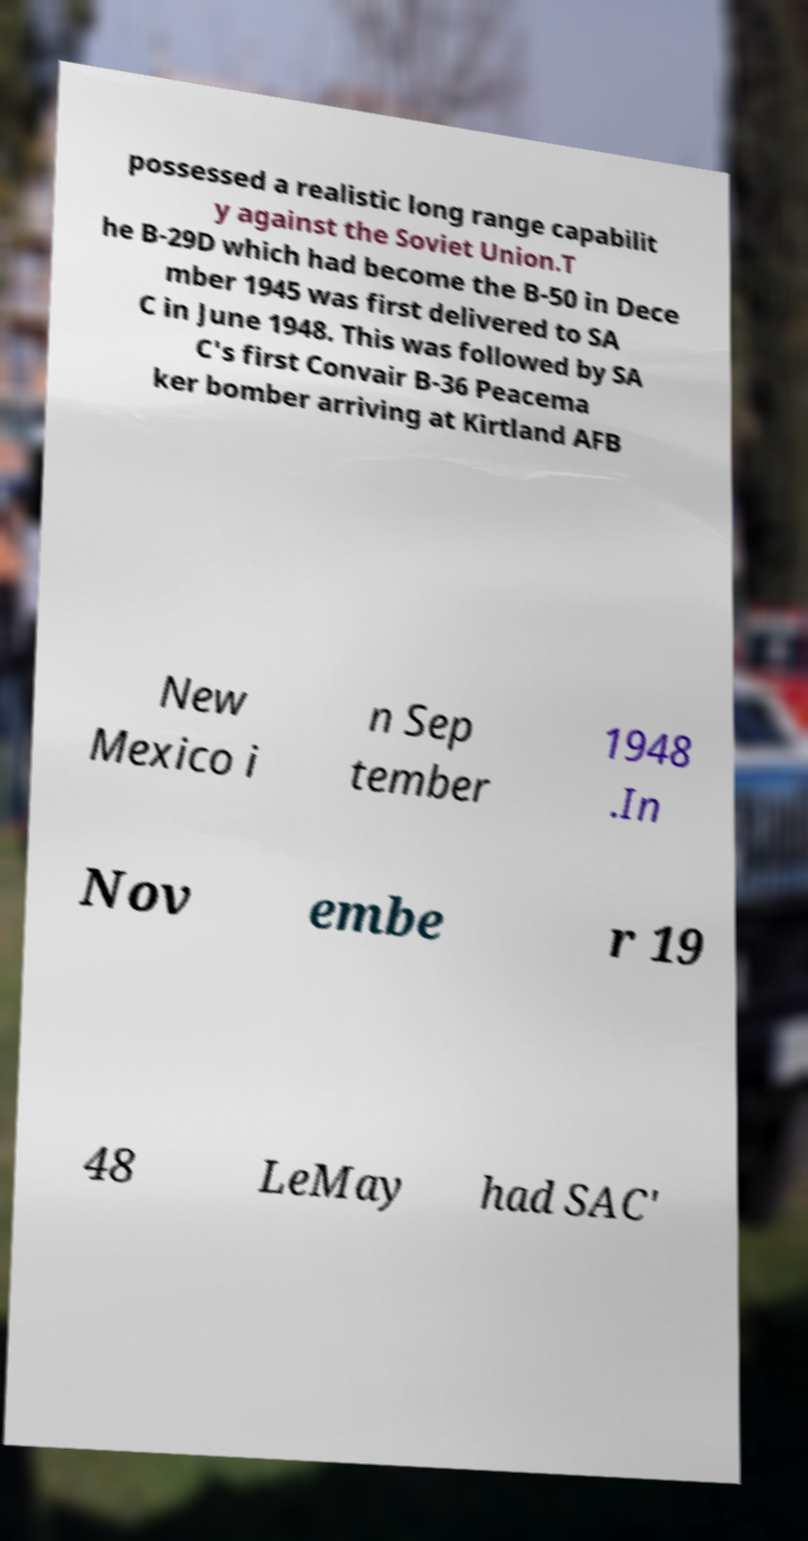There's text embedded in this image that I need extracted. Can you transcribe it verbatim? possessed a realistic long range capabilit y against the Soviet Union.T he B-29D which had become the B-50 in Dece mber 1945 was first delivered to SA C in June 1948. This was followed by SA C's first Convair B-36 Peacema ker bomber arriving at Kirtland AFB New Mexico i n Sep tember 1948 .In Nov embe r 19 48 LeMay had SAC' 